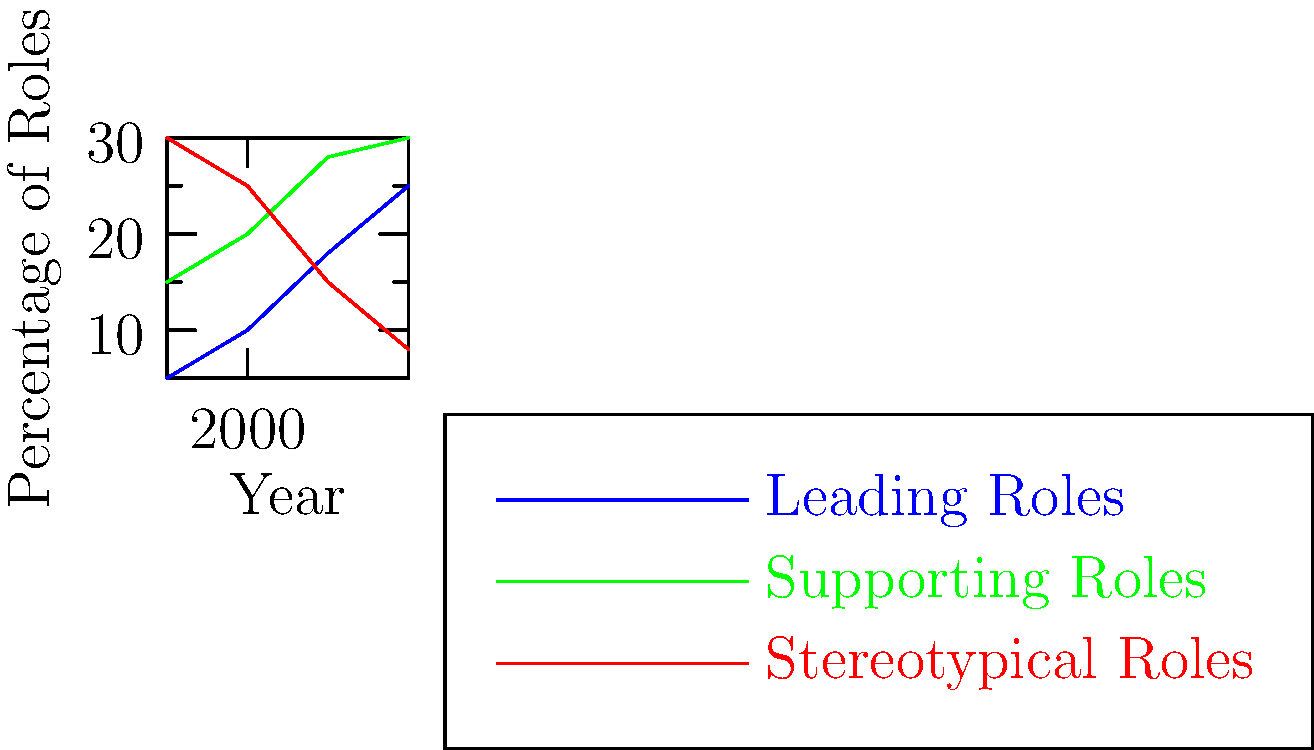Based on the graph showing the change in minority character roles in films from 1990 to 2020, which type of role shows the most significant increase, and what sociological implications might this trend have for media representation and racial stereotypes? To answer this question, we need to analyze the trends for each type of role:

1. Leading Roles (blue line):
   - 1990: 5%
   - 2020: 25%
   - Increase: 20 percentage points

2. Supporting Roles (green line):
   - 1990: 15%
   - 2020: 30%
   - Increase: 15 percentage points

3. Stereotypical Roles (red line):
   - 1990: 30%
   - 2020: 8%
   - Decrease: 22 percentage points

Leading Roles show the most significant increase (20 percentage points) over the 30-year period.

Sociological implications:

1. Increased representation: The rise in leading roles for minorities suggests a more inclusive media landscape, potentially reducing the impact of racial stereotypes.

2. Shifting power dynamics: More minorities in leading roles may indicate a change in how different racial groups are perceived in society.

3. Cultural influence: As minorities take on more prominent roles, it could lead to greater cultural understanding and empathy among diverse audiences.

4. Role model effect: Increased visibility of minorities in leading roles may inspire younger generations and contribute to positive self-image among minority groups.

5. Stereotype reduction: The decrease in stereotypical roles, coupled with the increase in leading and supporting roles, suggests a move towards more nuanced and authentic portrayals of minorities.

6. Industry changes: This trend may reflect broader societal changes and pressure on the film industry to address issues of diversity and representation.

7. Potential backlash: The rapid change in representation might lead to resistance or backlash from some segments of the audience or industry.
Answer: Leading Roles; increased representation, shifting power dynamics, cultural influence, role model effect, stereotype reduction, industry changes, potential backlash. 